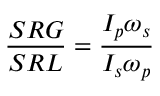Convert formula to latex. <formula><loc_0><loc_0><loc_500><loc_500>\frac { S R G } { S R L } = \frac { I _ { p } \omega _ { s } } { I _ { s } \omega _ { p } }</formula> 